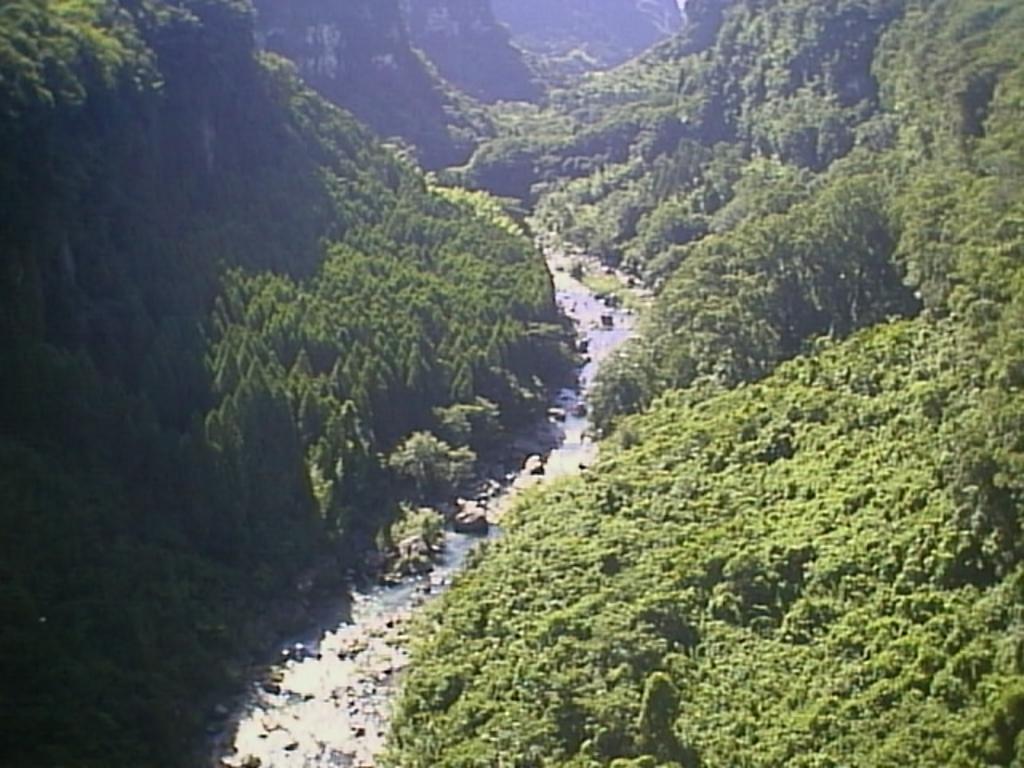In one or two sentences, can you explain what this image depicts? In this picture it looks like a river valley surrounded by tall trees and mountains. 